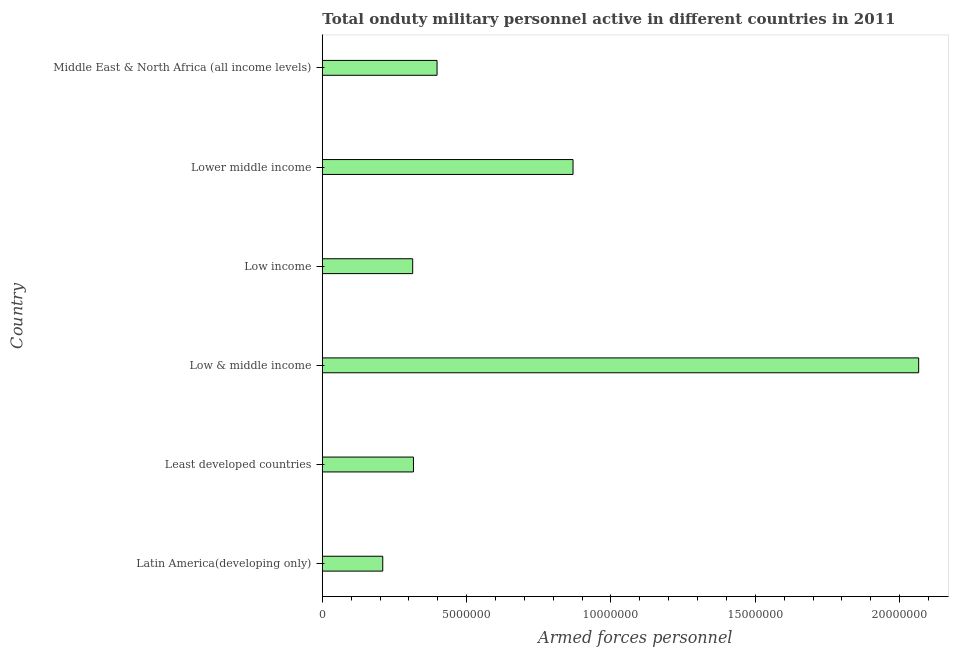Does the graph contain any zero values?
Provide a short and direct response. No. What is the title of the graph?
Keep it short and to the point. Total onduty military personnel active in different countries in 2011. What is the label or title of the X-axis?
Your answer should be very brief. Armed forces personnel. What is the number of armed forces personnel in Low income?
Provide a short and direct response. 3.13e+06. Across all countries, what is the maximum number of armed forces personnel?
Provide a short and direct response. 2.07e+07. Across all countries, what is the minimum number of armed forces personnel?
Your answer should be compact. 2.09e+06. In which country was the number of armed forces personnel maximum?
Offer a very short reply. Low & middle income. In which country was the number of armed forces personnel minimum?
Provide a succinct answer. Latin America(developing only). What is the sum of the number of armed forces personnel?
Keep it short and to the point. 4.17e+07. What is the difference between the number of armed forces personnel in Latin America(developing only) and Least developed countries?
Your answer should be compact. -1.06e+06. What is the average number of armed forces personnel per country?
Your answer should be compact. 6.95e+06. What is the median number of armed forces personnel?
Offer a very short reply. 3.57e+06. In how many countries, is the number of armed forces personnel greater than 18000000 ?
Your response must be concise. 1. What is the ratio of the number of armed forces personnel in Low & middle income to that in Lower middle income?
Provide a succinct answer. 2.38. Is the difference between the number of armed forces personnel in Lower middle income and Middle East & North Africa (all income levels) greater than the difference between any two countries?
Your answer should be compact. No. What is the difference between the highest and the second highest number of armed forces personnel?
Keep it short and to the point. 1.20e+07. What is the difference between the highest and the lowest number of armed forces personnel?
Your response must be concise. 1.86e+07. How many bars are there?
Offer a very short reply. 6. Are all the bars in the graph horizontal?
Provide a succinct answer. Yes. How many countries are there in the graph?
Give a very brief answer. 6. What is the difference between two consecutive major ticks on the X-axis?
Offer a very short reply. 5.00e+06. Are the values on the major ticks of X-axis written in scientific E-notation?
Make the answer very short. No. What is the Armed forces personnel of Latin America(developing only)?
Ensure brevity in your answer.  2.09e+06. What is the Armed forces personnel of Least developed countries?
Keep it short and to the point. 3.16e+06. What is the Armed forces personnel in Low & middle income?
Ensure brevity in your answer.  2.07e+07. What is the Armed forces personnel of Low income?
Make the answer very short. 3.13e+06. What is the Armed forces personnel in Lower middle income?
Your answer should be very brief. 8.69e+06. What is the Armed forces personnel in Middle East & North Africa (all income levels)?
Your answer should be compact. 3.97e+06. What is the difference between the Armed forces personnel in Latin America(developing only) and Least developed countries?
Offer a terse response. -1.06e+06. What is the difference between the Armed forces personnel in Latin America(developing only) and Low & middle income?
Keep it short and to the point. -1.86e+07. What is the difference between the Armed forces personnel in Latin America(developing only) and Low income?
Your answer should be compact. -1.04e+06. What is the difference between the Armed forces personnel in Latin America(developing only) and Lower middle income?
Your answer should be very brief. -6.59e+06. What is the difference between the Armed forces personnel in Latin America(developing only) and Middle East & North Africa (all income levels)?
Ensure brevity in your answer.  -1.88e+06. What is the difference between the Armed forces personnel in Least developed countries and Low & middle income?
Make the answer very short. -1.75e+07. What is the difference between the Armed forces personnel in Least developed countries and Low income?
Provide a succinct answer. 2.62e+04. What is the difference between the Armed forces personnel in Least developed countries and Lower middle income?
Offer a very short reply. -5.53e+06. What is the difference between the Armed forces personnel in Least developed countries and Middle East & North Africa (all income levels)?
Keep it short and to the point. -8.18e+05. What is the difference between the Armed forces personnel in Low & middle income and Low income?
Your answer should be compact. 1.75e+07. What is the difference between the Armed forces personnel in Low & middle income and Lower middle income?
Offer a very short reply. 1.20e+07. What is the difference between the Armed forces personnel in Low & middle income and Middle East & North Africa (all income levels)?
Offer a terse response. 1.67e+07. What is the difference between the Armed forces personnel in Low income and Lower middle income?
Provide a succinct answer. -5.55e+06. What is the difference between the Armed forces personnel in Low income and Middle East & North Africa (all income levels)?
Ensure brevity in your answer.  -8.44e+05. What is the difference between the Armed forces personnel in Lower middle income and Middle East & North Africa (all income levels)?
Ensure brevity in your answer.  4.71e+06. What is the ratio of the Armed forces personnel in Latin America(developing only) to that in Least developed countries?
Ensure brevity in your answer.  0.66. What is the ratio of the Armed forces personnel in Latin America(developing only) to that in Low & middle income?
Your answer should be compact. 0.1. What is the ratio of the Armed forces personnel in Latin America(developing only) to that in Low income?
Offer a terse response. 0.67. What is the ratio of the Armed forces personnel in Latin America(developing only) to that in Lower middle income?
Your response must be concise. 0.24. What is the ratio of the Armed forces personnel in Latin America(developing only) to that in Middle East & North Africa (all income levels)?
Make the answer very short. 0.53. What is the ratio of the Armed forces personnel in Least developed countries to that in Low & middle income?
Your answer should be compact. 0.15. What is the ratio of the Armed forces personnel in Least developed countries to that in Lower middle income?
Your response must be concise. 0.36. What is the ratio of the Armed forces personnel in Least developed countries to that in Middle East & North Africa (all income levels)?
Make the answer very short. 0.79. What is the ratio of the Armed forces personnel in Low & middle income to that in Low income?
Your answer should be compact. 6.6. What is the ratio of the Armed forces personnel in Low & middle income to that in Lower middle income?
Keep it short and to the point. 2.38. What is the ratio of the Armed forces personnel in Low & middle income to that in Middle East & North Africa (all income levels)?
Keep it short and to the point. 5.2. What is the ratio of the Armed forces personnel in Low income to that in Lower middle income?
Offer a terse response. 0.36. What is the ratio of the Armed forces personnel in Low income to that in Middle East & North Africa (all income levels)?
Your response must be concise. 0.79. What is the ratio of the Armed forces personnel in Lower middle income to that in Middle East & North Africa (all income levels)?
Your answer should be compact. 2.19. 